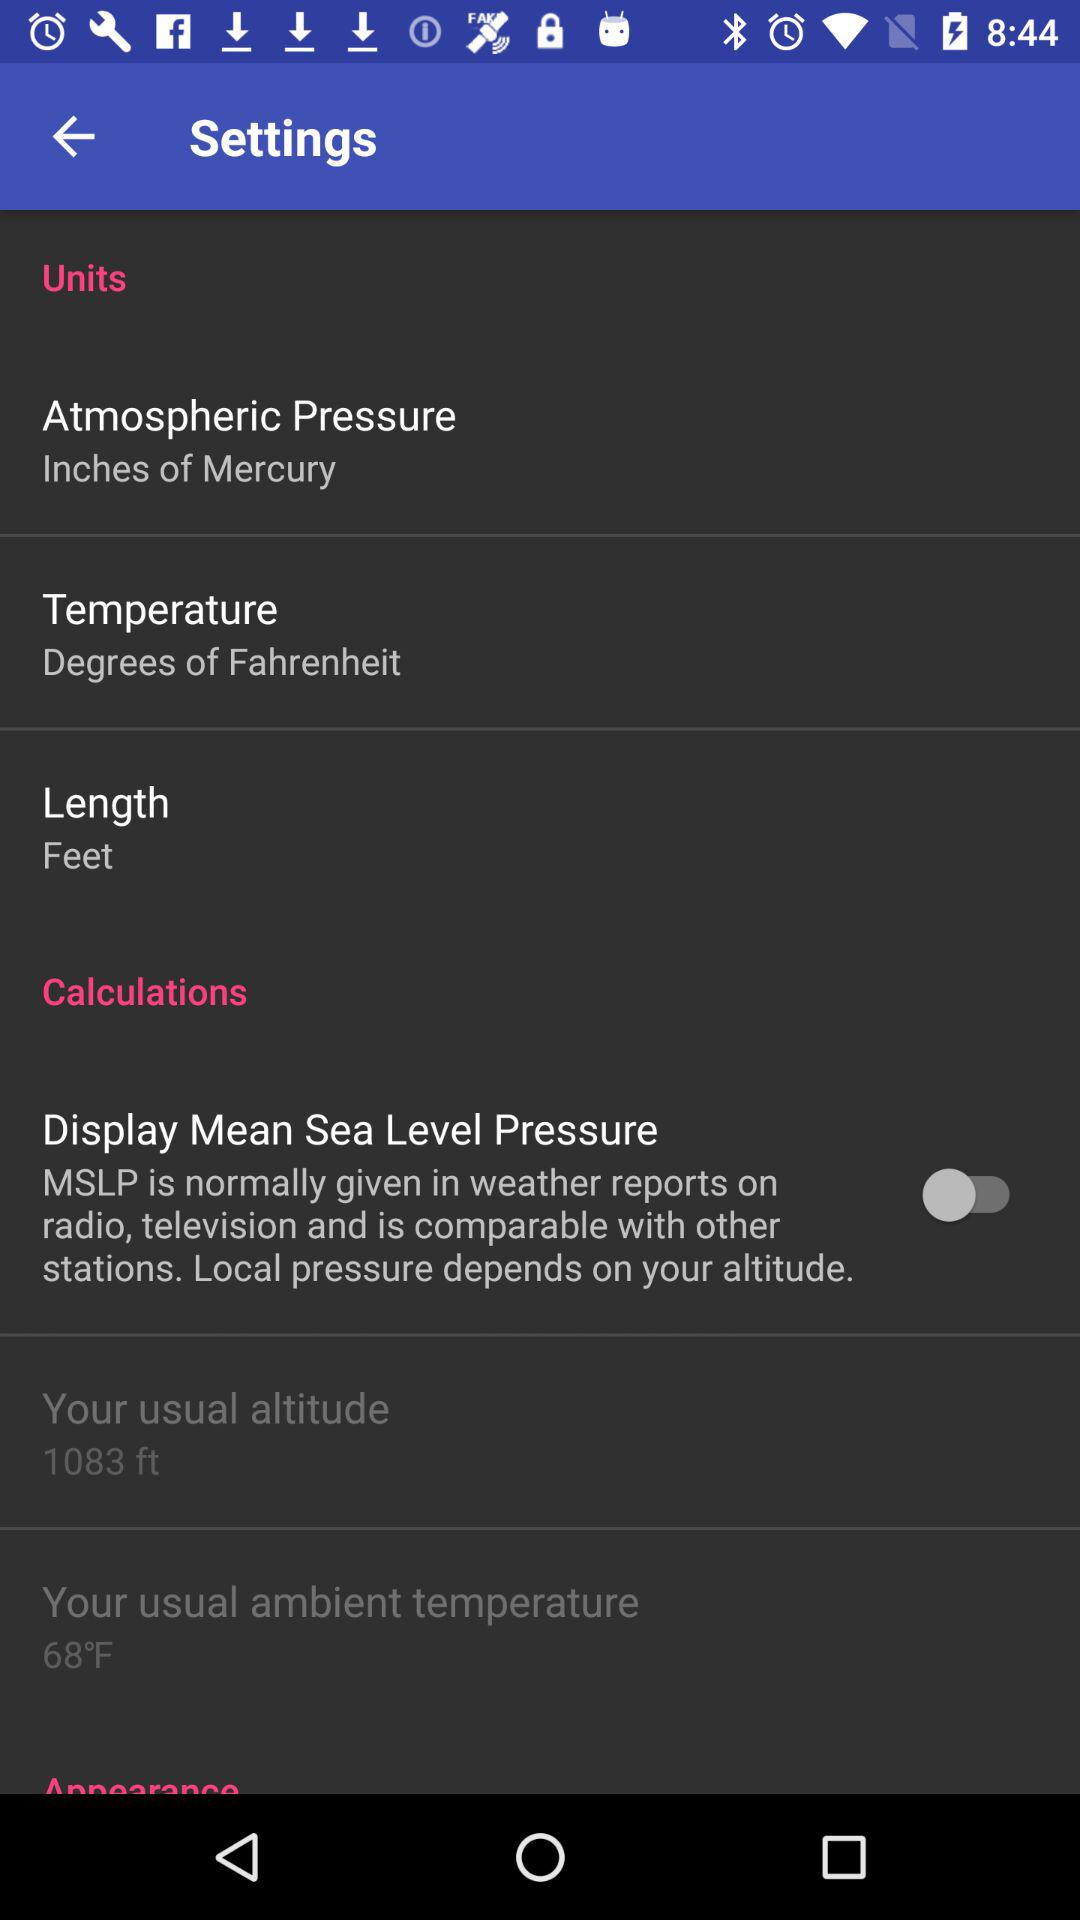What is the unit of length? The unit of length is feet. 